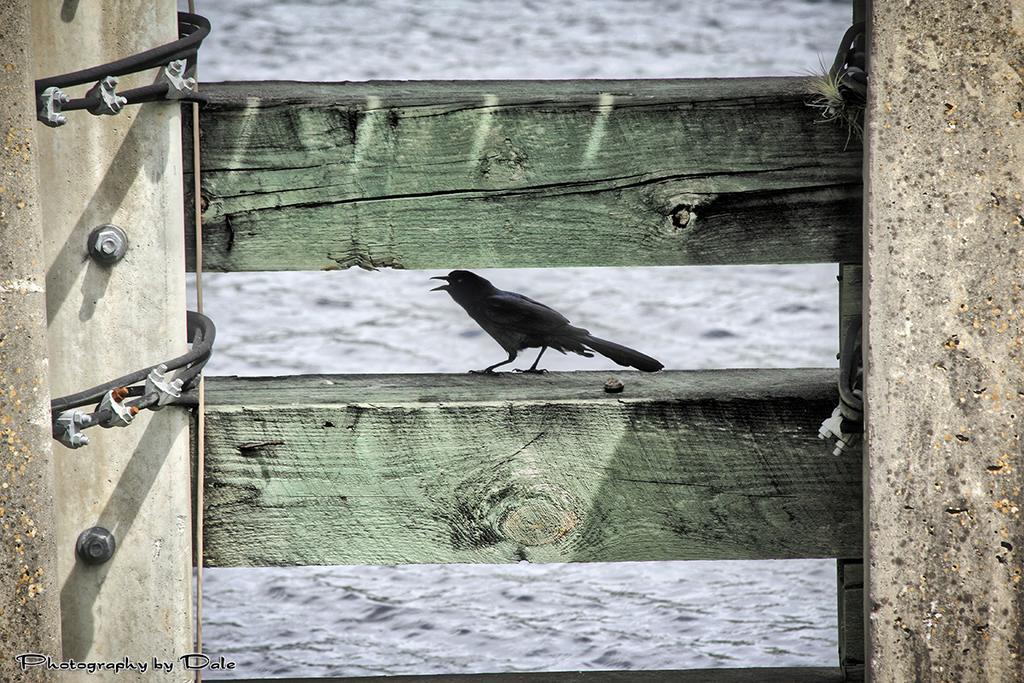Can you describe this image briefly? In this picture I can see 2 wooden planks in front and I see a bird on a wooden plank and I see the bird if of black color. On the left bottom of this picture I can see the watermark. On the left side of this image I see few black color things and I see nuts and bolts. 